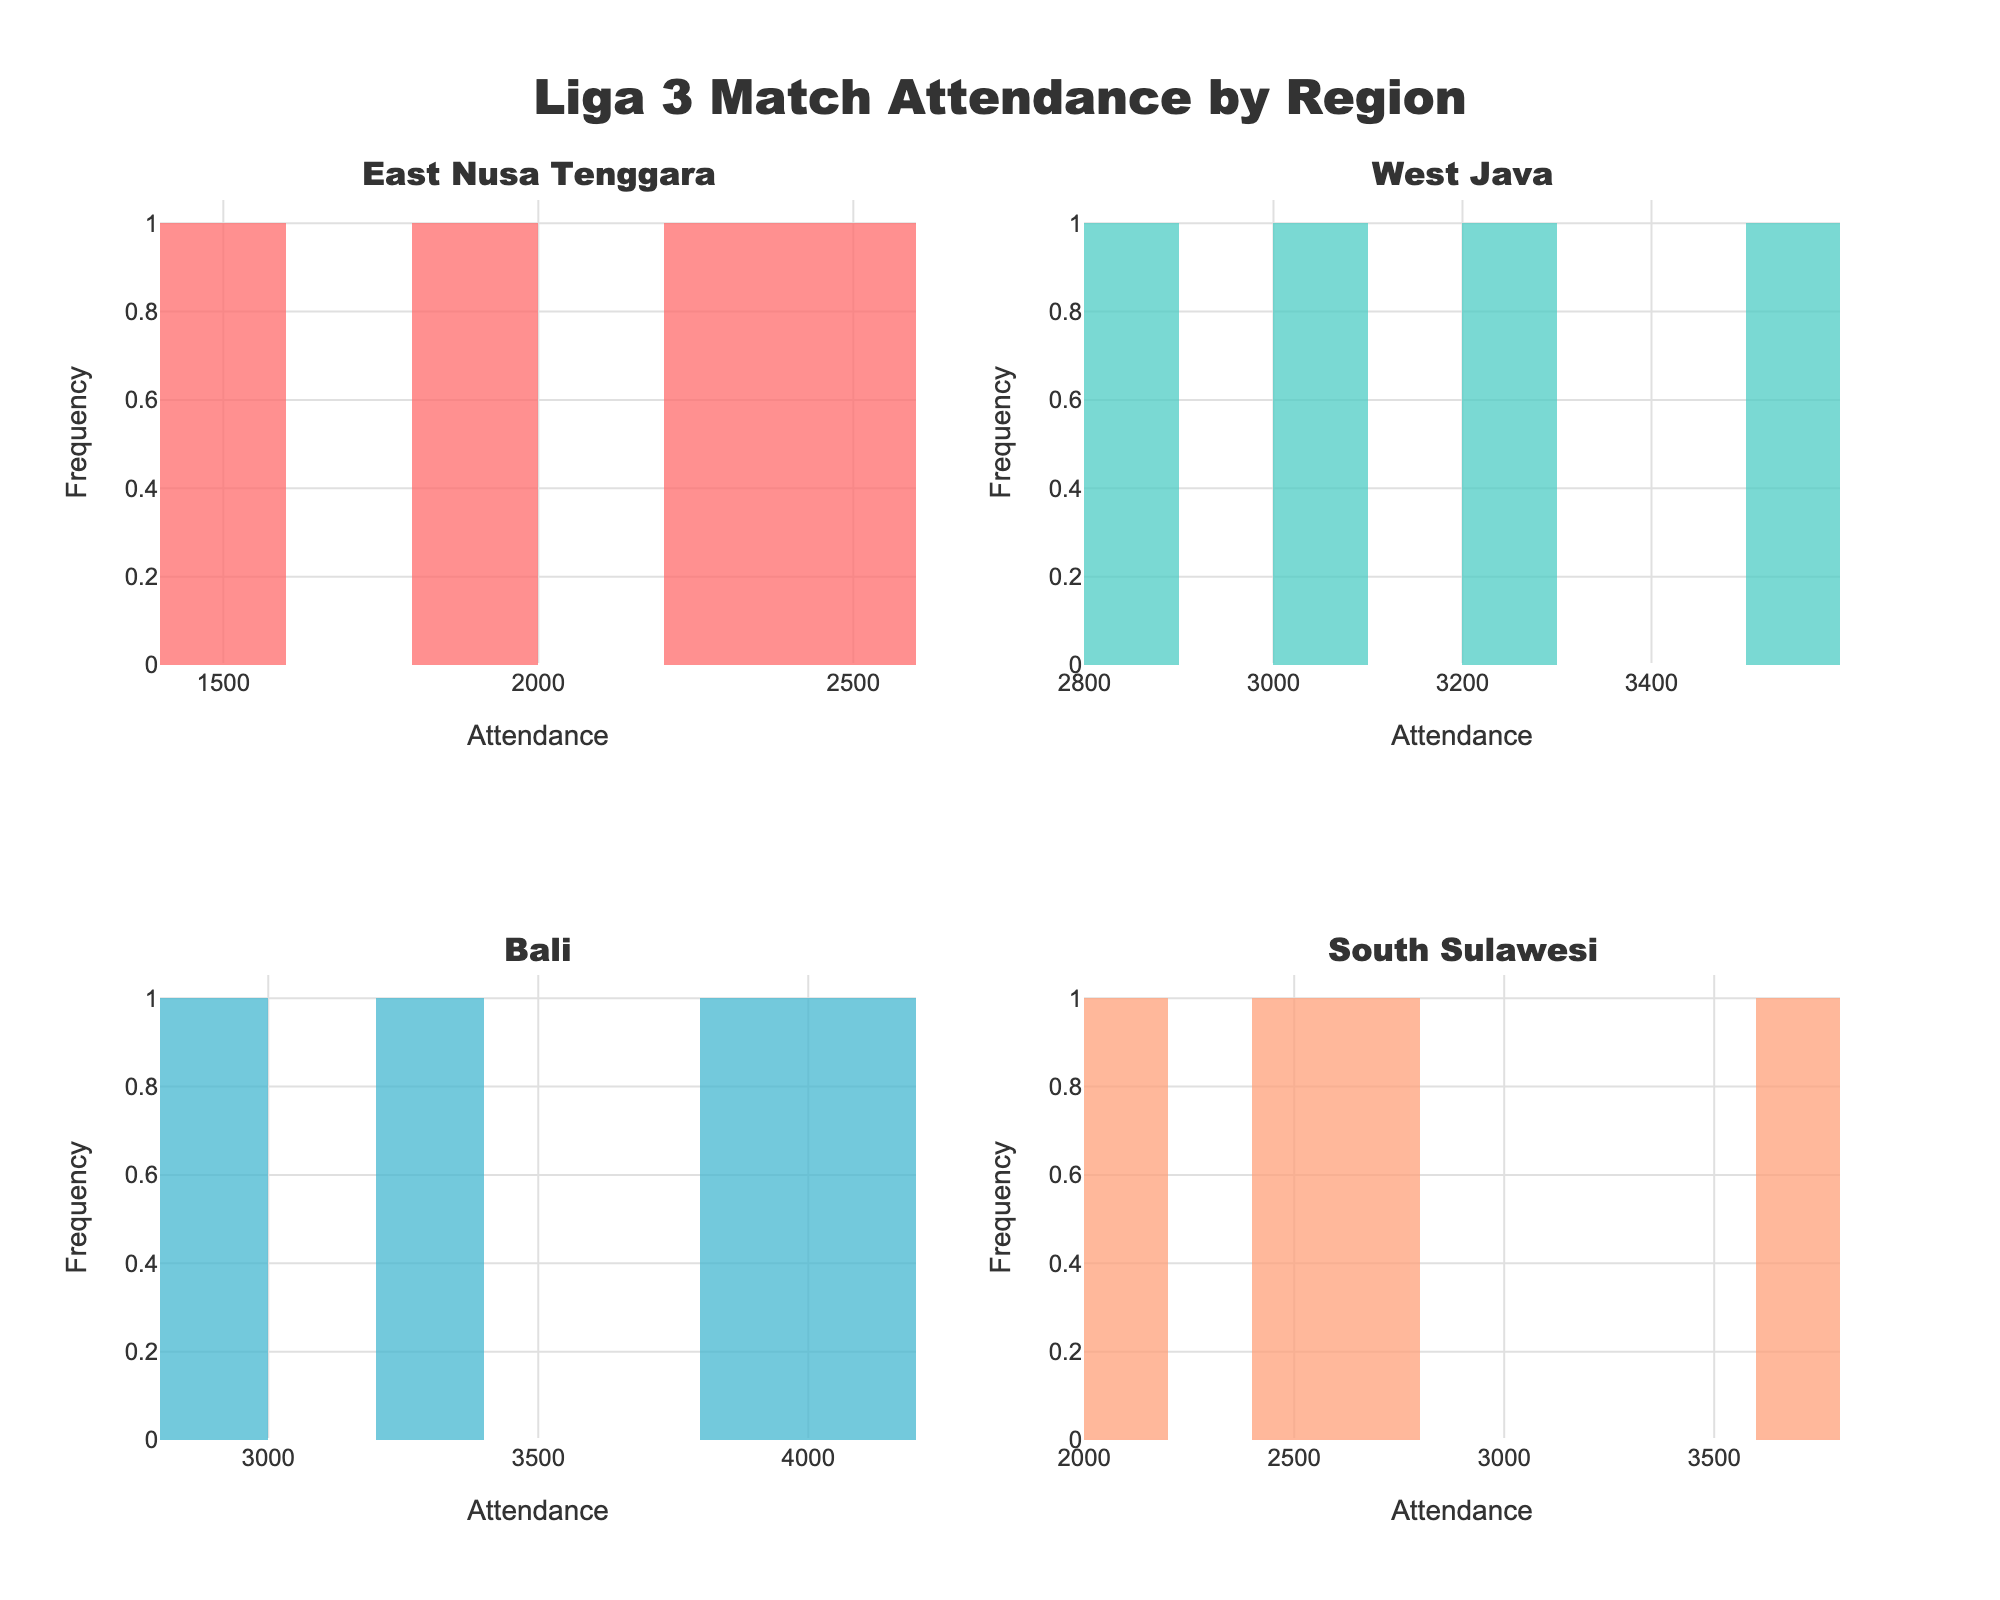What's the title of the figure? The title of the figure is clearly mentioned at the top center of the figure.
Answer: Liga 3 Match Attendance by Region Which region has the highest attendance? By comparing the histograms, the one with the highest attendance bar belongs to Bali as most of its games have high attendance figures.
Answer: Bali How many regions are represented in the figure? Each subplot corresponds to a unique region, and there are four subplots.
Answer: 4 Which subplot has the lowest attendance? The subplot with the lowest attendance can be identified by the histogram bars with the lowest values. For the East Nusa Tenggara region, the lowest attendance is around 1500.
Answer: East Nusa Tenggara What is the attendance range for matches in South Sulawesi? By looking at the South Sulawesi subplot, the range can be determined by the lowest and highest attendance values on the x-axis.
Answer: 2100 to 3700 Which region has the greatest variability in attendance? The region with the greatest variability can be identified by the spread of the bars across the x-axis. West Java has attendance values spread wider compared to the other regions.
Answer: West Java What is the minimum attendance recorded in the Bali region? The minimum attendance can be found by identifying the leftmost bar on the Bali subplot.
Answer: 2900 Which region has the most games with very high attendance? The region with the most games with very high attendance can be determined by the frequency of bars on the higher end of the x-axis. Bali has the most occurrences of high attendance values.
Answer: Bali How does the attendance in East Nusa Tenggara compare to South Sulawesi? By comparing the histograms for East Nusa Tenggara and South Sulawesi, East Nusa Tenggara generally has lower attendance values compared to South Sulawesi.
Answer: Lower What is the average attendance for matches in West Java? Summing the attendance figures provided for West Java (3500, 3000, 2800, and 3200) and then dividing by the number of games (4) will give the average attendance. Calculation: (3500 + 3000 + 2800 + 3200) / 4 = 3125.
Answer: 3125 